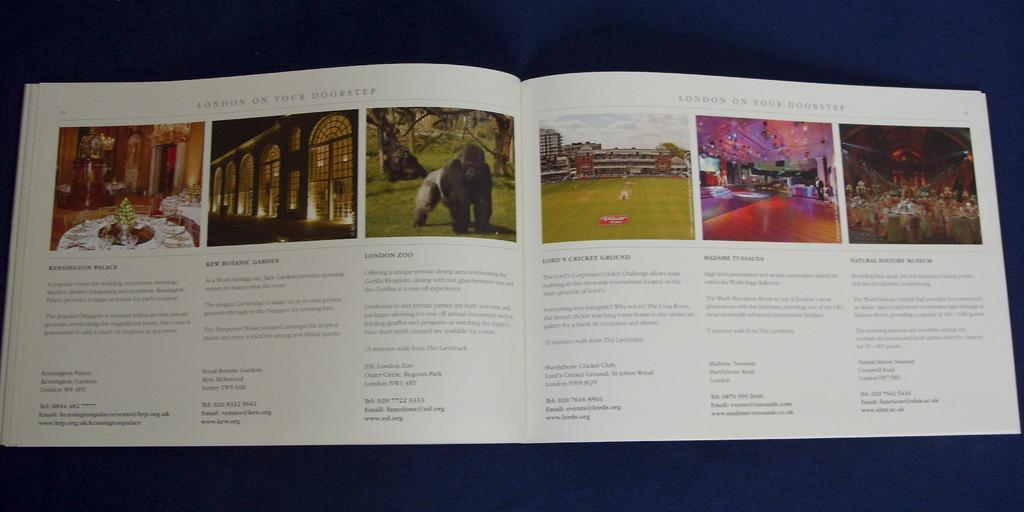<image>
Render a clear and concise summary of the photo. A book lies open and on its pages are pictures of and information on, Londons tourist attractions. 